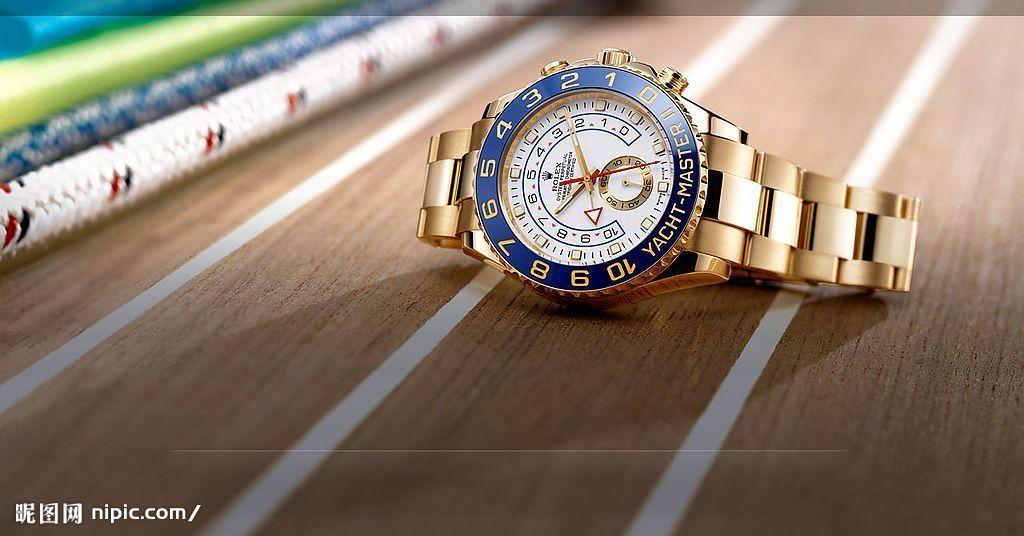<image>
Create a compact narrative representing the image presented. A Rolex watch points to the space between the numbers 2 and 3 